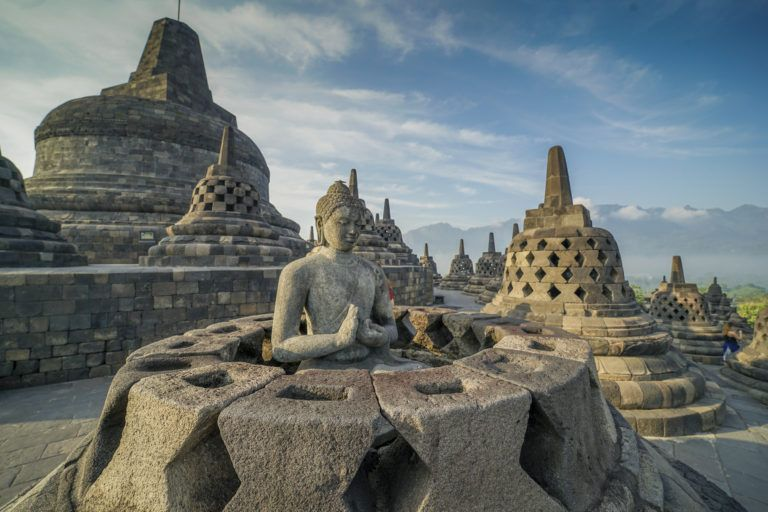What are some fascinating architectural features of the Borobodur Temple? Borobodur Temple is a marvel of Buddhist architecture, notable for several fascinating features. The temple is constructed in the shape of a mandala, symbolizing the universe in Buddhist cosmology. It comprises nine stacked platforms: six square and three circular, topped by a central dome. The temple’s walls and balustrades are adorned with an impressive 2,672 relief panels and 504 Buddha statues, each meticulously carved. The central dome is surrounded by 72 Buddha statues seated inside perforated stupas, creating a striking visual impact. The temple’s design is not just aesthetic; it’s also an embodiment of spiritual philosophy, guiding visitors on a physical and symbolic path to enlightenment as they ascend its levels. 